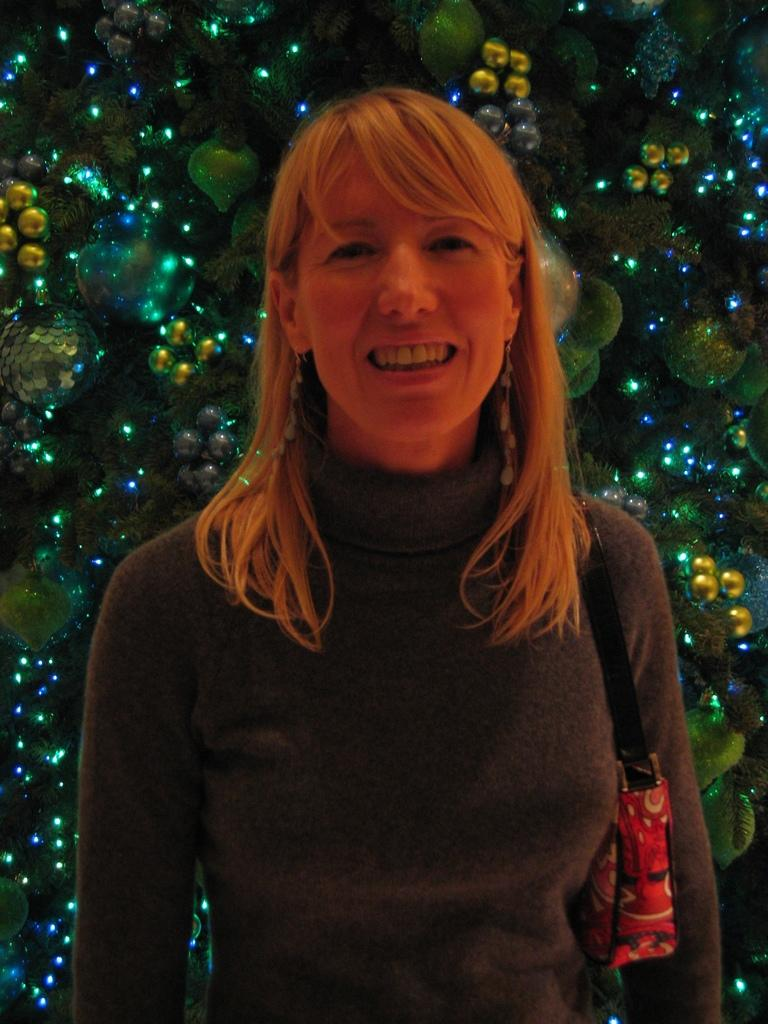What is the woman in the image doing? The woman is standing in the image and smiling. What is the woman holding in the image? The woman is holding a wire bag in the image. What can be seen in the background of the image? The background of the image contains decorative items, including lights. Can you describe the decorative items in the background? The decorative items in the background include lights, but the specific nature of the other decorative items cannot be determined from the image. What type of jelly can be seen on the woman's shoes in the image? There is no jelly visible on the woman's shoes or anywhere else in the image. 